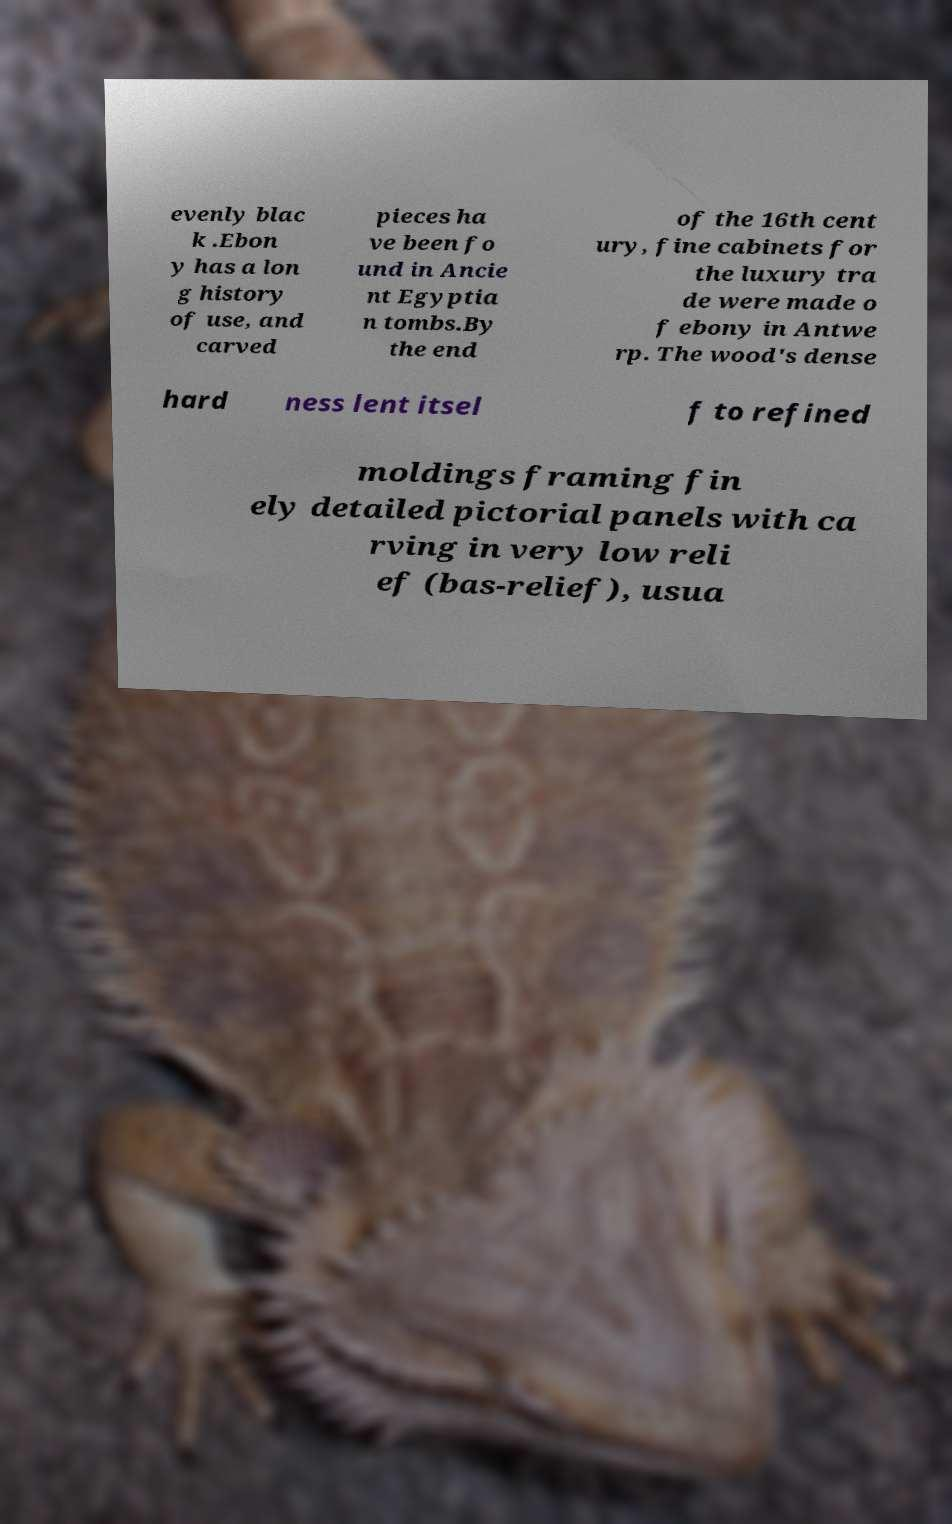For documentation purposes, I need the text within this image transcribed. Could you provide that? evenly blac k .Ebon y has a lon g history of use, and carved pieces ha ve been fo und in Ancie nt Egyptia n tombs.By the end of the 16th cent ury, fine cabinets for the luxury tra de were made o f ebony in Antwe rp. The wood's dense hard ness lent itsel f to refined moldings framing fin ely detailed pictorial panels with ca rving in very low reli ef (bas-relief), usua 